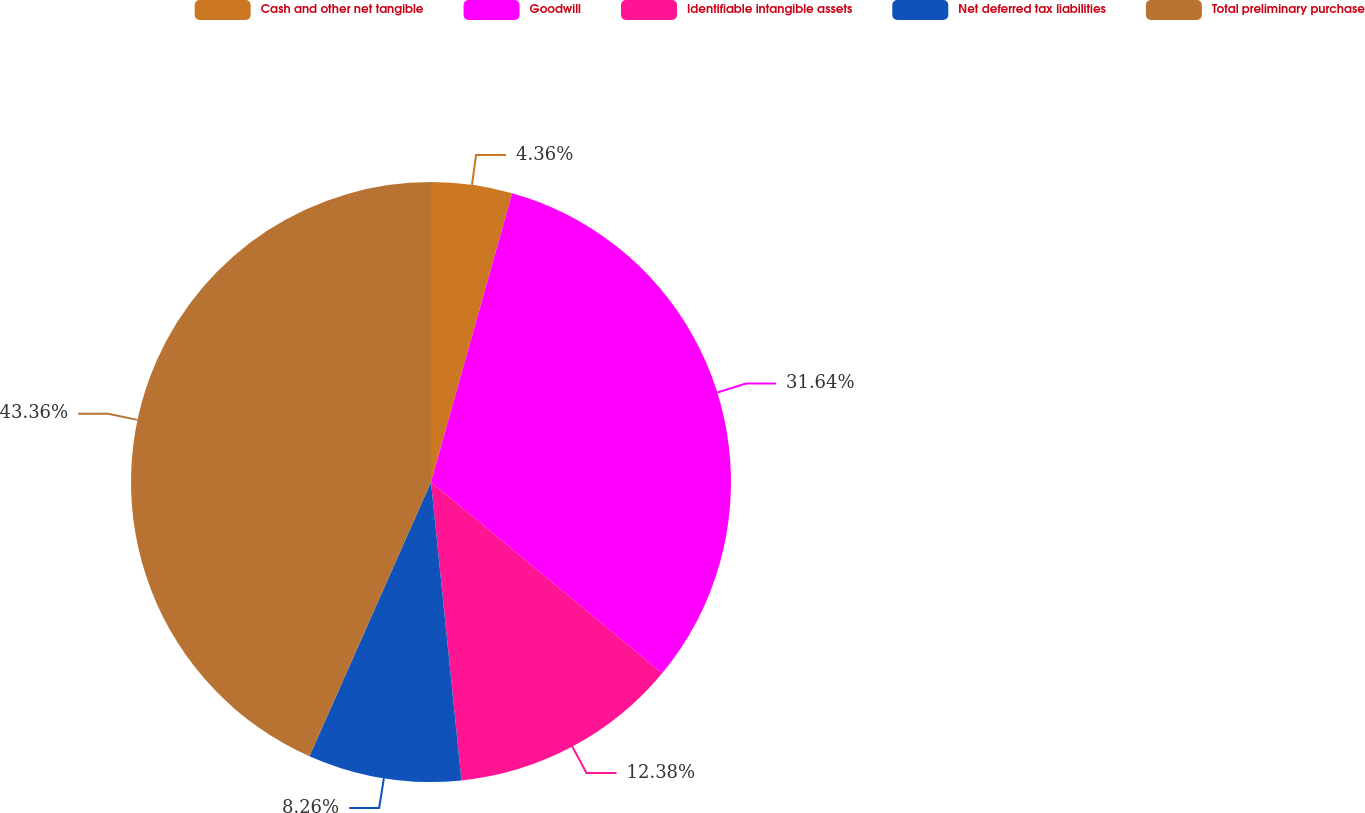<chart> <loc_0><loc_0><loc_500><loc_500><pie_chart><fcel>Cash and other net tangible<fcel>Goodwill<fcel>Identifiable intangible assets<fcel>Net deferred tax liabilities<fcel>Total preliminary purchase<nl><fcel>4.36%<fcel>31.64%<fcel>12.38%<fcel>8.26%<fcel>43.36%<nl></chart> 